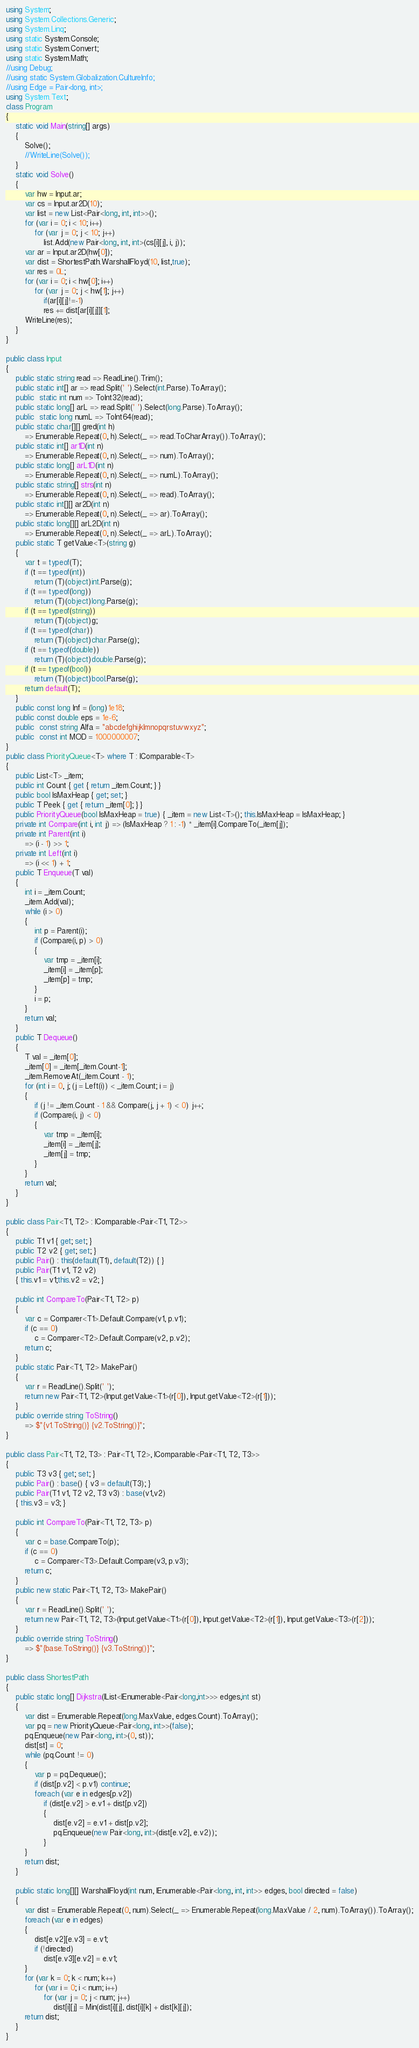Convert code to text. <code><loc_0><loc_0><loc_500><loc_500><_C#_>using System;
using System.Collections.Generic;
using System.Linq;
using static System.Console;
using static System.Convert;
using static System.Math;
//using Debug;
//using static System.Globalization.CultureInfo;
//using Edge = Pair<long, int>;
using System.Text;
class Program
{ 
    static void Main(string[] args)
    {
        Solve();
        //WriteLine(Solve());
    }
    static void Solve()
    {
        var hw = Input.ar;
        var cs = Input.ar2D(10);
        var list = new List<Pair<long, int, int>>();
        for (var i = 0; i < 10; i++)
            for (var j = 0; j < 10; j++)
                list.Add(new Pair<long, int, int>(cs[i][j], i, j));
        var ar = Input.ar2D(hw[0]);
        var dist = ShortestPath.WarshallFloyd(10, list,true);
        var res = 0L;
        for (var i = 0; i < hw[0]; i++)
            for (var j = 0; j < hw[1]; j++)
                if(ar[i][j]!=-1)
                res += dist[ar[i][j]][1];
        WriteLine(res);
    }
}

public class Input
{
    public static string read => ReadLine().Trim();
    public static int[] ar => read.Split(' ').Select(int.Parse).ToArray();
    public  static int num => ToInt32(read);
    public static long[] arL => read.Split(' ').Select(long.Parse).ToArray();
    public  static long numL => ToInt64(read);
    public static char[][] gred(int h) 
        => Enumerable.Repeat(0, h).Select(_ => read.ToCharArray()).ToArray();
    public static int[] ar1D(int n)
        => Enumerable.Repeat(0, n).Select(_ => num).ToArray();
    public static long[] arL1D(int n)
        => Enumerable.Repeat(0, n).Select(_ => numL).ToArray();
    public static string[] strs(int n)
        => Enumerable.Repeat(0, n).Select(_ => read).ToArray();
    public static int[][] ar2D(int n)
        => Enumerable.Repeat(0, n).Select(_ => ar).ToArray();
    public static long[][] arL2D(int n)
        => Enumerable.Repeat(0, n).Select(_ => arL).ToArray();
    public static T getValue<T>(string g)
    {
        var t = typeof(T);
        if (t == typeof(int))
            return (T)(object)int.Parse(g);
        if (t == typeof(long))
            return (T)(object)long.Parse(g);
        if (t == typeof(string))
            return (T)(object)g;
        if (t == typeof(char))
            return (T)(object)char.Parse(g);
        if (t == typeof(double))
            return (T)(object)double.Parse(g);
        if (t == typeof(bool))
            return (T)(object)bool.Parse(g);
        return default(T);
    }
    public const long Inf = (long)1e18;
    public const double eps = 1e-6;
    public  const string Alfa = "abcdefghijklmnopqrstuvwxyz";
    public  const int MOD = 1000000007;
}
public class PriorityQueue<T> where T : IComparable<T>
{
    public List<T> _item;
    public int Count { get { return _item.Count; } }
    public bool IsMaxHeap { get; set; }
    public T Peek { get { return _item[0]; } }
    public PriorityQueue(bool IsMaxHeap = true) { _item = new List<T>(); this.IsMaxHeap = IsMaxHeap; }
    private int Compare(int i, int j) => (IsMaxHeap ? 1 : -1) * _item[i].CompareTo(_item[j]);
    private int Parent(int i)
        => (i - 1) >> 1;
    private int Left(int i)
        => (i << 1) + 1;
    public T Enqueue(T val)
    {
        int i = _item.Count;
        _item.Add(val);
        while (i > 0)
        {
            int p = Parent(i);
            if (Compare(i, p) > 0)
            {
                var tmp = _item[i];
                _item[i] = _item[p];
                _item[p] = tmp;
            }
            i = p;
        }
        return val;
    }
    public T Dequeue()
    {
        T val = _item[0];
        _item[0] = _item[_item.Count-1];
        _item.RemoveAt(_item.Count - 1);
        for (int i = 0, j; (j = Left(i)) < _item.Count; i = j)
        {
            if (j != _item.Count - 1 && Compare(j, j + 1) < 0) j++;
            if (Compare(i, j) < 0)
            {
                var tmp = _item[i];
                _item[i] = _item[j];
                _item[j] = tmp;
            }
        }
        return val;
    }
}

public class Pair<T1, T2> : IComparable<Pair<T1, T2>>
{
    public T1 v1 { get; set; }
    public T2 v2 { get; set; }
    public Pair() : this(default(T1), default(T2)) { }
    public Pair(T1 v1, T2 v2)
    { this.v1 = v1;this.v2 = v2; }

    public int CompareTo(Pair<T1, T2> p)
    {
        var c = Comparer<T1>.Default.Compare(v1, p.v1);
        if (c == 0)
            c = Comparer<T2>.Default.Compare(v2, p.v2);
        return c;
    }
    public static Pair<T1, T2> MakePair()
    {
        var r = ReadLine().Split(' ');
        return new Pair<T1, T2>(Input.getValue<T1>(r[0]), Input.getValue<T2>(r[1]));
    }
    public override string ToString()
        => $"{v1.ToString()} {v2.ToString()}";
}

public class Pair<T1, T2, T3> : Pair<T1, T2>, IComparable<Pair<T1, T2, T3>>
{
    public T3 v3 { get; set; }
    public Pair() : base() { v3 = default(T3); }
    public Pair(T1 v1, T2 v2, T3 v3) : base(v1,v2)
    { this.v3 = v3; }
    
    public int CompareTo(Pair<T1, T2, T3> p)
    {
        var c = base.CompareTo(p);
        if (c == 0)
            c = Comparer<T3>.Default.Compare(v3, p.v3);
        return c;
    }
    public new static Pair<T1, T2, T3> MakePair()
    {
        var r = ReadLine().Split(' ');
        return new Pair<T1, T2, T3>(Input.getValue<T1>(r[0]), Input.getValue<T2>(r[1]), Input.getValue<T3>(r[2]));
    }
    public override string ToString()
        => $"{base.ToString()} {v3.ToString()}";
}

public class ShortestPath
{
    public static long[] Dijkstra(IList<IEnumerable<Pair<long,int>>> edges,int st)
    {
        var dist = Enumerable.Repeat(long.MaxValue, edges.Count).ToArray();
        var pq = new PriorityQueue<Pair<long, int>>(false);
        pq.Enqueue(new Pair<long, int>(0, st));
        dist[st] = 0;
        while (pq.Count != 0)
        {
            var p = pq.Dequeue();
            if (dist[p.v2] < p.v1) continue;
            foreach (var e in edges[p.v2])
                if (dist[e.v2] > e.v1 + dist[p.v2])
                {
                    dist[e.v2] = e.v1 + dist[p.v2];
                    pq.Enqueue(new Pair<long, int>(dist[e.v2], e.v2));
                }
        }
        return dist;
    }

    public static long[][] WarshallFloyd(int num, IEnumerable<Pair<long, int, int>> edges, bool directed = false)
    {
        var dist = Enumerable.Repeat(0, num).Select(_ => Enumerable.Repeat(long.MaxValue / 2, num).ToArray()).ToArray();
        foreach (var e in edges)
        {
            dist[e.v2][e.v3] = e.v1;
            if (!directed)
                dist[e.v3][e.v2] = e.v1;
        }
        for (var k = 0; k < num; k++)
            for (var i = 0; i < num; i++)
                for (var j = 0; j < num; j++)
                    dist[i][j] = Min(dist[i][j], dist[i][k] + dist[k][j]);
        return dist;
    }
}
</code> 